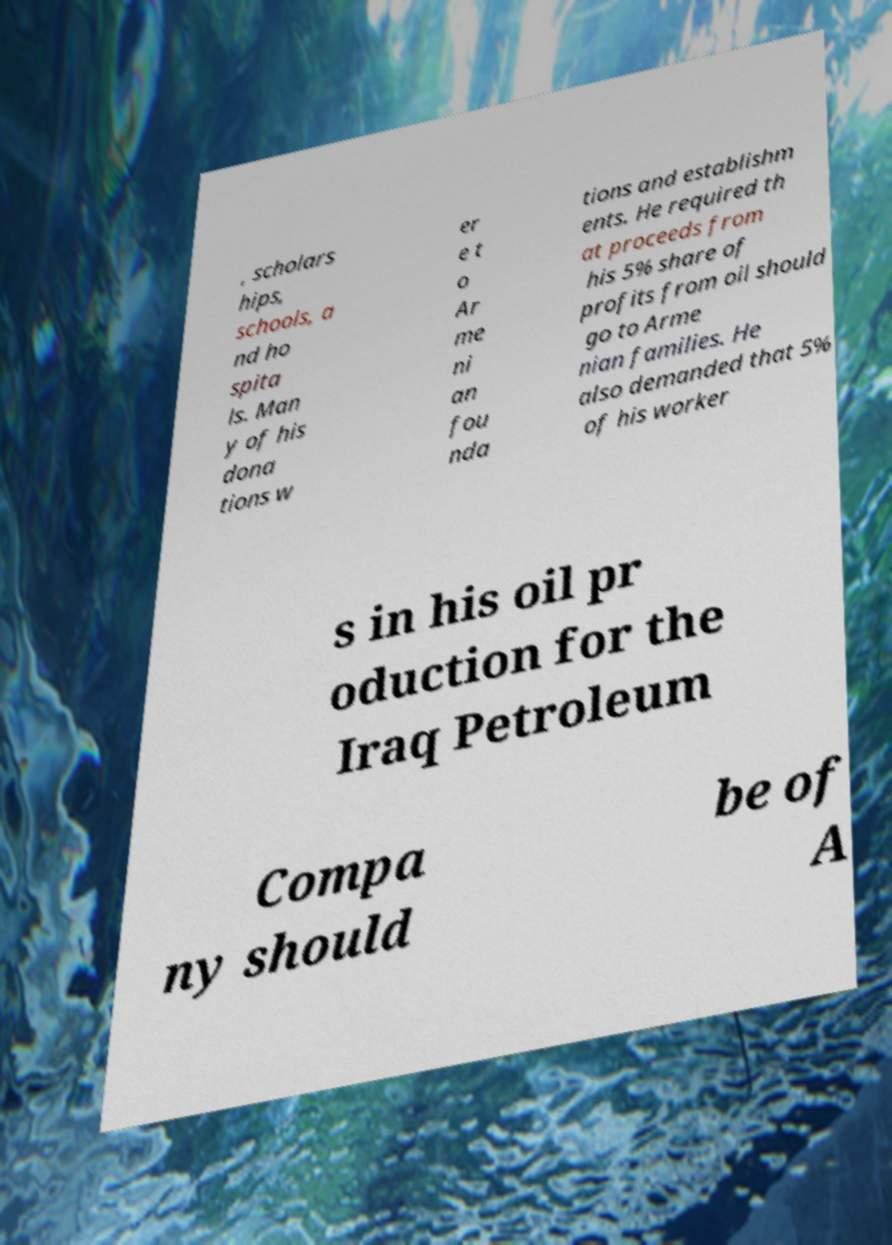Please identify and transcribe the text found in this image. , scholars hips, schools, a nd ho spita ls. Man y of his dona tions w er e t o Ar me ni an fou nda tions and establishm ents. He required th at proceeds from his 5% share of profits from oil should go to Arme nian families. He also demanded that 5% of his worker s in his oil pr oduction for the Iraq Petroleum Compa ny should be of A 